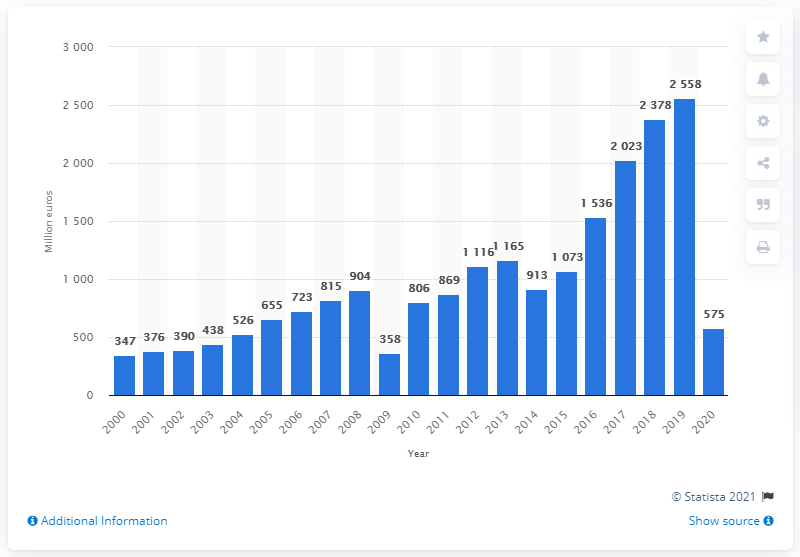Indicate a few pertinent items in this graphic. The adidas Group's worldwide income before taxes in 2020 was approximately 575. 